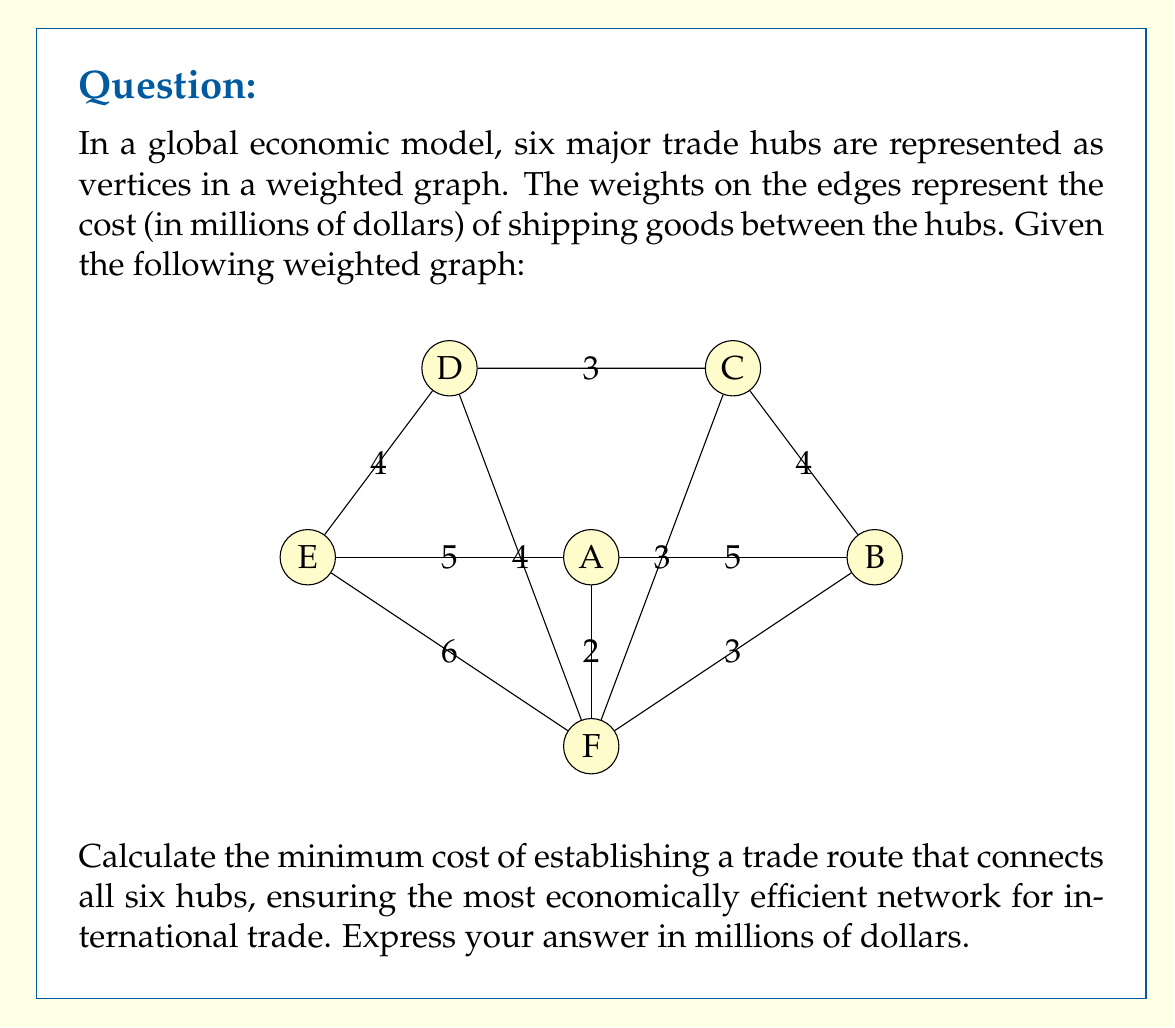Can you answer this question? To solve this problem, we need to find the minimum spanning tree (MST) of the given weighted graph. The MST represents the most economically efficient network connecting all trade hubs with the minimum total cost. We can use Kruskal's algorithm to find the MST:

1) Sort all edges by weight in ascending order:
   (A,F): 2
   (B,F): 3
   (C,D): 3
   (C,F): 3
   (A,B): 5
   (B,C): 4
   (D,E): 4
   (D,F): 4
   (A,E): 5
   (E,F): 6

2) Start with an empty set of edges and add edges one by one, ensuring no cycles are formed:

   - Add (A,F): 2
   - Add (B,F): 3
   - Add (C,D): 3
   - Add (C,F): 3
   - Add (D,E): 4

3) At this point, we have added 5 edges, which is sufficient to connect all 6 vertices without forming any cycles. This forms our MST.

4) Calculate the total cost by summing the weights of the edges in the MST:

   $$ \text{Total Cost} = 2 + 3 + 3 + 3 + 4 = 15 $$

Therefore, the minimum cost of establishing a trade route that connects all six hubs is 15 million dollars.
Answer: $15 million 